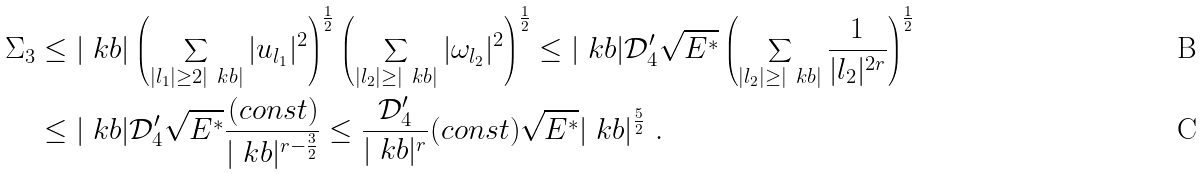Convert formula to latex. <formula><loc_0><loc_0><loc_500><loc_500>\Sigma _ { 3 } & \leq | \ k b | \left ( \sum _ { | l _ { 1 } | \geq 2 | \ k b | } | u _ { l _ { 1 } } | ^ { 2 } \right ) ^ { \frac { 1 } { 2 } } \left ( \sum _ { | l _ { 2 } | \geq | \ k b | } | \omega _ { l _ { 2 } } | ^ { 2 } \right ) ^ { \frac { 1 } { 2 } } \leq | \ k b | \mathcal { D } _ { 4 } ^ { \prime } \sqrt { E ^ { * } } \left ( \sum _ { | l _ { 2 } | \geq | \ k b | } \frac { 1 } { | l _ { 2 } | ^ { 2 r } } \right ) ^ { \frac { 1 } { 2 } } \\ & \leq | \ k b | \mathcal { D } _ { 4 } ^ { \prime } \sqrt { E ^ { * } } \frac { ( c o n s t ) } { | \ k b | ^ { r - \frac { 3 } { 2 } } } \leq \frac { \mathcal { D } _ { 4 } ^ { \prime } } { | \ k b | ^ { r } } ( c o n s t ) \sqrt { E ^ { * } } | \ k b | ^ { \frac { 5 } { 2 } } \ .</formula> 